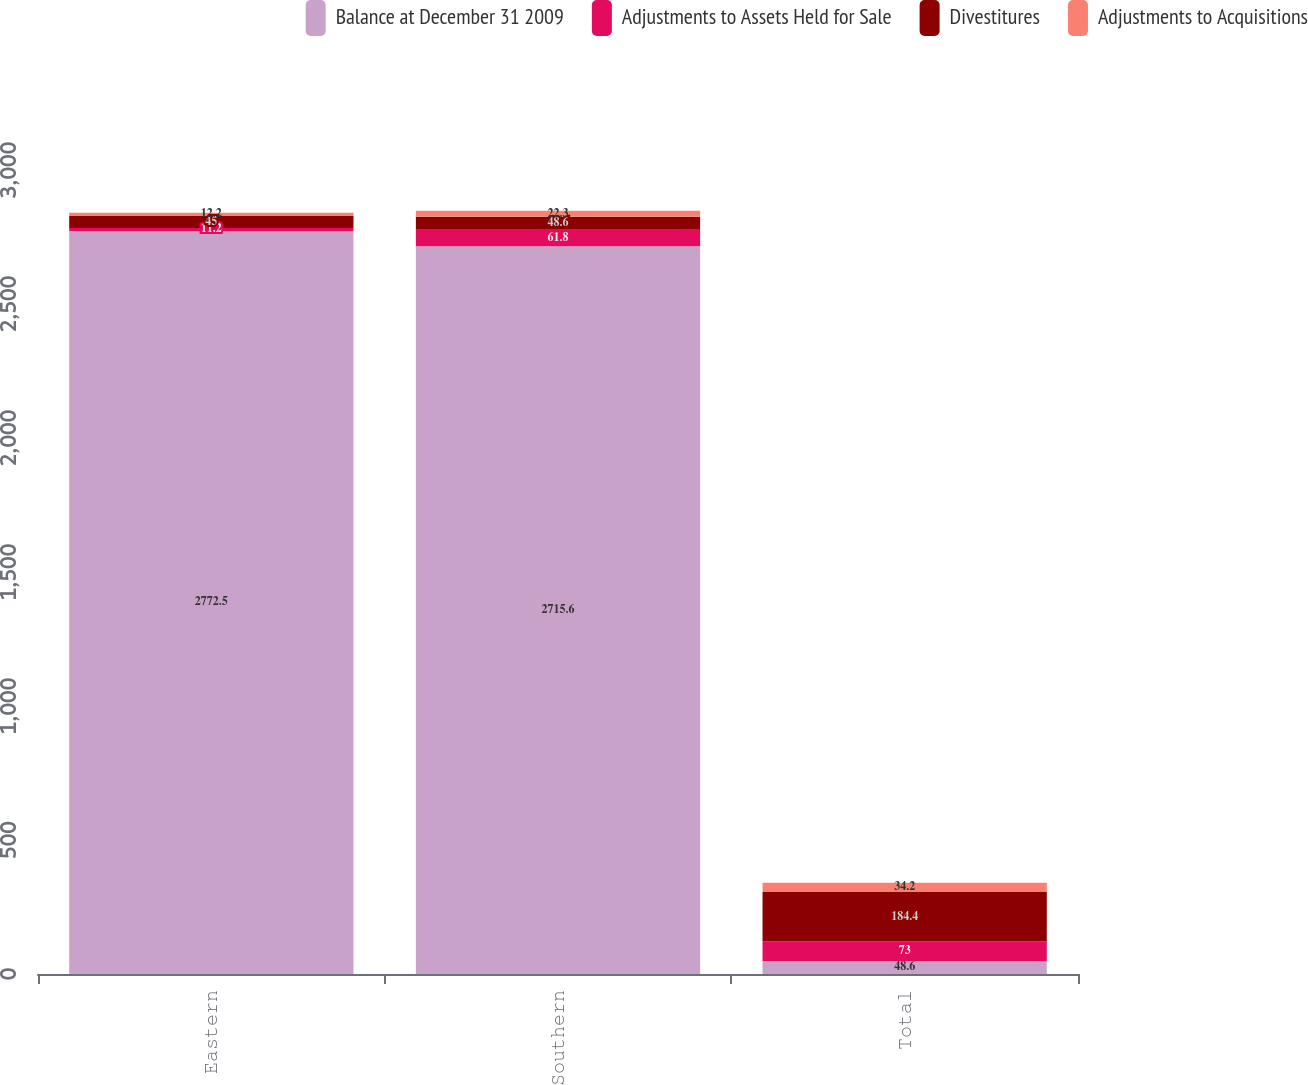Convert chart to OTSL. <chart><loc_0><loc_0><loc_500><loc_500><stacked_bar_chart><ecel><fcel>Eastern<fcel>Southern<fcel>Total<nl><fcel>Balance at December 31 2009<fcel>2772.5<fcel>2715.6<fcel>48.6<nl><fcel>Adjustments to Assets Held for Sale<fcel>11.2<fcel>61.8<fcel>73<nl><fcel>Divestitures<fcel>45<fcel>48.6<fcel>184.4<nl><fcel>Adjustments to Acquisitions<fcel>12.2<fcel>22.3<fcel>34.2<nl></chart> 